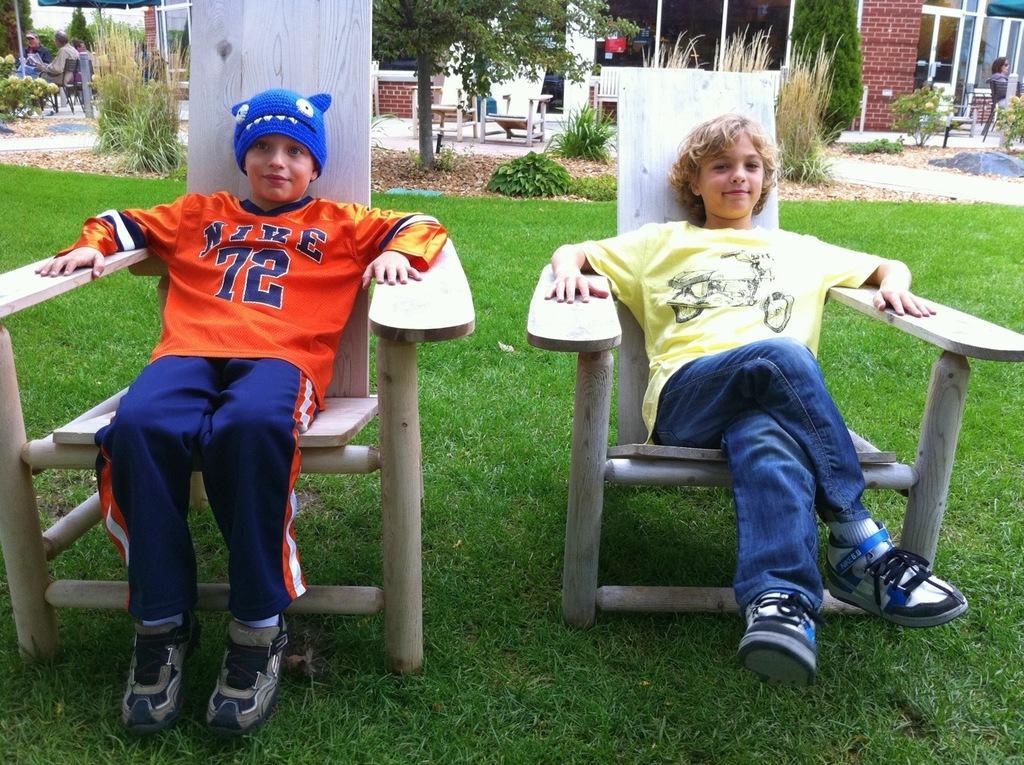Could you give a brief overview of what you see in this image? Here two boys are sitting on the chairs. At background I can see small plants,trees and bushes. This looks like a building with glass doors. At background I can see few people sitting on the chair. 